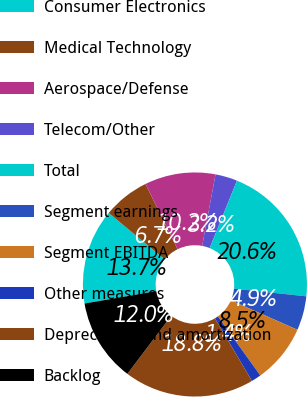Convert chart to OTSL. <chart><loc_0><loc_0><loc_500><loc_500><pie_chart><fcel>Consumer Electronics<fcel>Medical Technology<fcel>Aerospace/Defense<fcel>Telecom/Other<fcel>Total<fcel>Segment earnings<fcel>Segment EBITDA<fcel>Other measures<fcel>Depreciation and amortization<fcel>Backlog<nl><fcel>13.74%<fcel>6.7%<fcel>10.22%<fcel>3.18%<fcel>20.56%<fcel>4.94%<fcel>8.46%<fcel>1.42%<fcel>18.8%<fcel>11.98%<nl></chart> 